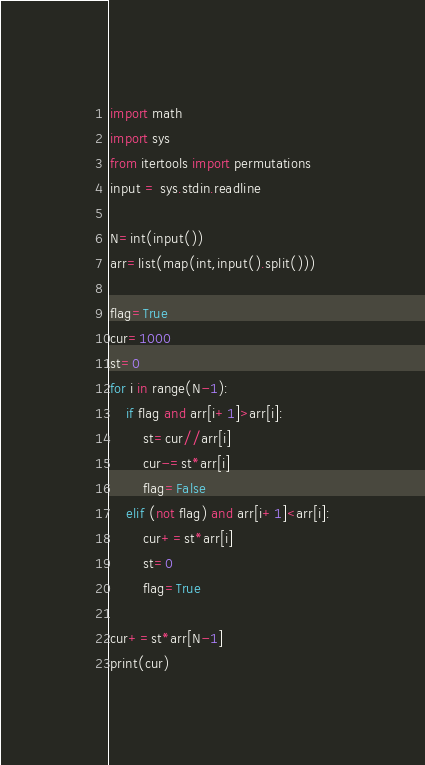<code> <loc_0><loc_0><loc_500><loc_500><_Python_>import math
import sys
from itertools import permutations
input = sys.stdin.readline

N=int(input())
arr=list(map(int,input().split()))

flag=True
cur=1000
st=0
for i in range(N-1):
    if flag and arr[i+1]>arr[i]:
        st=cur//arr[i]
        cur-=st*arr[i]
        flag=False
    elif (not flag) and arr[i+1]<arr[i]:
        cur+=st*arr[i]
        st=0
        flag=True

cur+=st*arr[N-1]
print(cur)</code> 